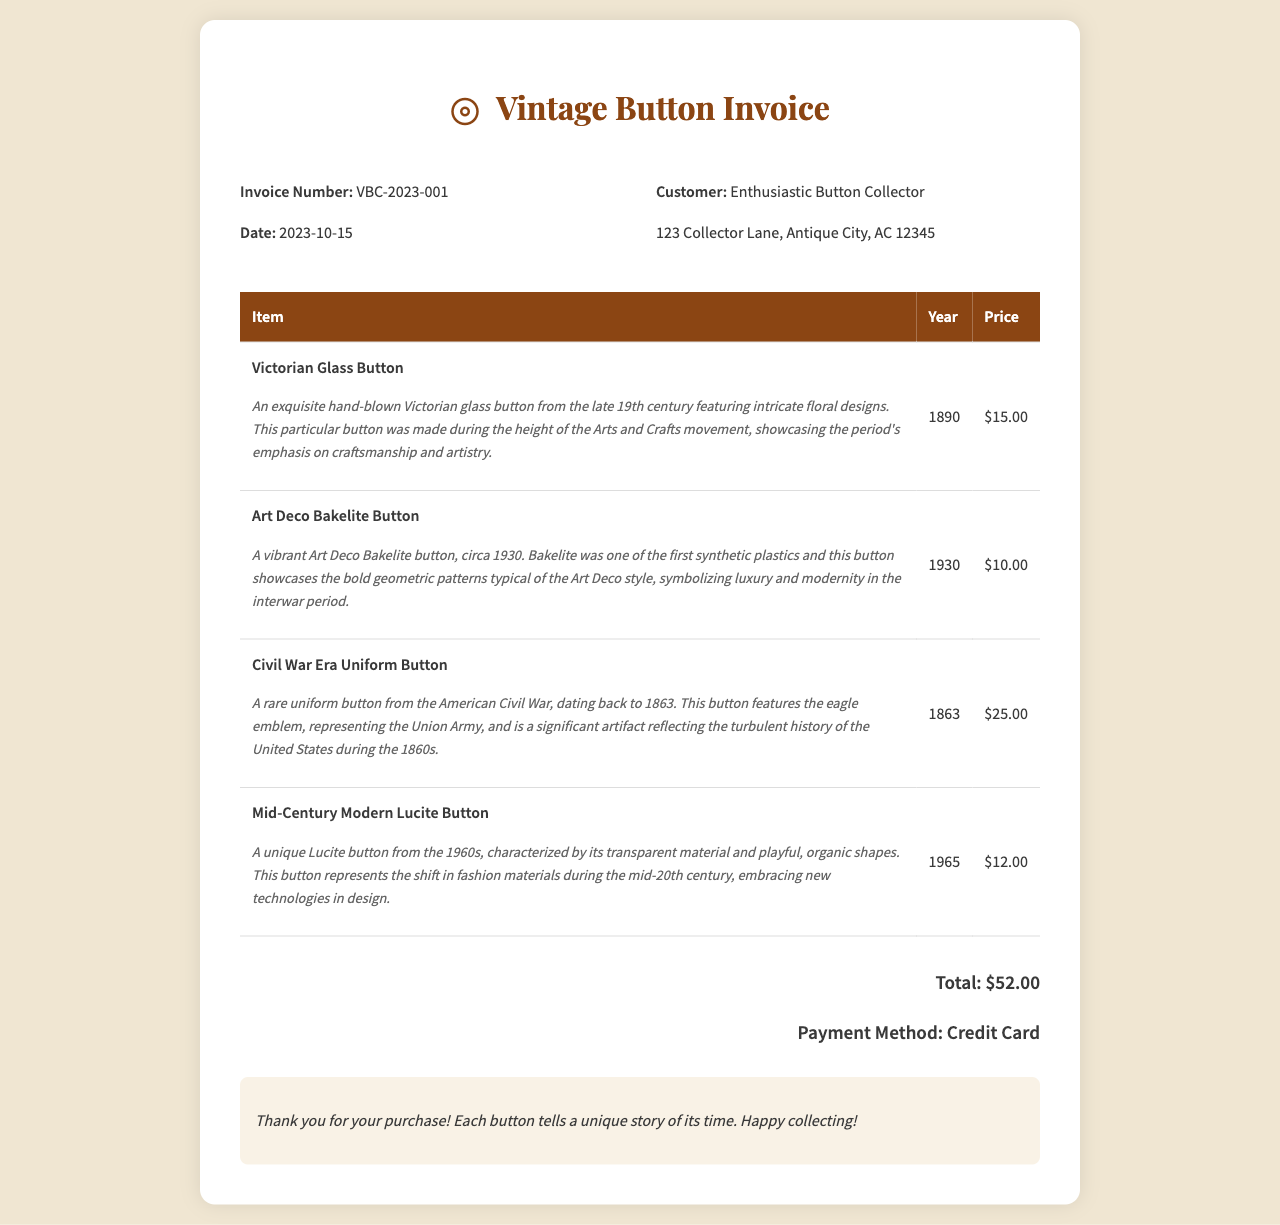what is the invoice number? The invoice number is stated clearly in the document as VBC-2023-001.
Answer: VBC-2023-001 what is the total amount due? The total amount due is found at the bottom of the invoice, which sums up the prices of all items.
Answer: $52.00 how many items are listed in the invoice? The document provides a table with four unique items listed for purchase.
Answer: 4 which item is from the year 1863? The Civil War Era Uniform Button is referenced in the items and is noted to be from the year 1863.
Answer: Civil War Era Uniform Button what is the historical significance of the Art Deco Bakelite Button? The explanation in the document mentions it represents luxury and modernity during the interwar period.
Answer: Symbolizing luxury and modernity when was the Victorian Glass Button made? The invoice provides the date for the Victorian Glass Button as 1890.
Answer: 1890 how did the invoice payment take place? The payment method is stated in the total section of the document, which details how the purchase was paid for.
Answer: Credit Card what type of material characterizes the Mid-Century Modern Lucite Button? The item description specifies that this button is characterized by its transparent material.
Answer: Transparent material what is the customer's address? The customer's address is provided in the customer details section of the invoice.
Answer: 123 Collector Lane, Antique City, AC 12345 